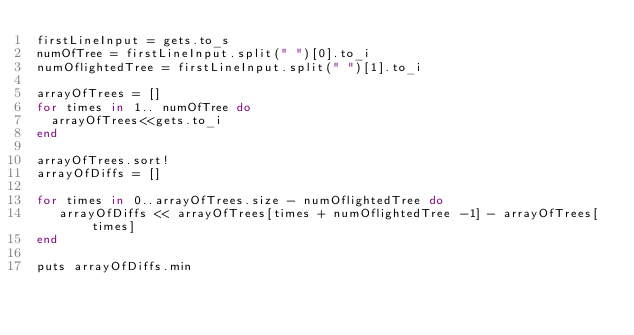Convert code to text. <code><loc_0><loc_0><loc_500><loc_500><_Ruby_>firstLineInput = gets.to_s
numOfTree = firstLineInput.split(" ")[0].to_i
numOflightedTree = firstLineInput.split(" ")[1].to_i

arrayOfTrees = []
for times in 1.. numOfTree do
  arrayOfTrees<<gets.to_i
end

arrayOfTrees.sort!
arrayOfDiffs = []

for times in 0..arrayOfTrees.size - numOflightedTree do 
   arrayOfDiffs << arrayOfTrees[times + numOflightedTree -1] - arrayOfTrees[times]
end

puts arrayOfDiffs.min</code> 